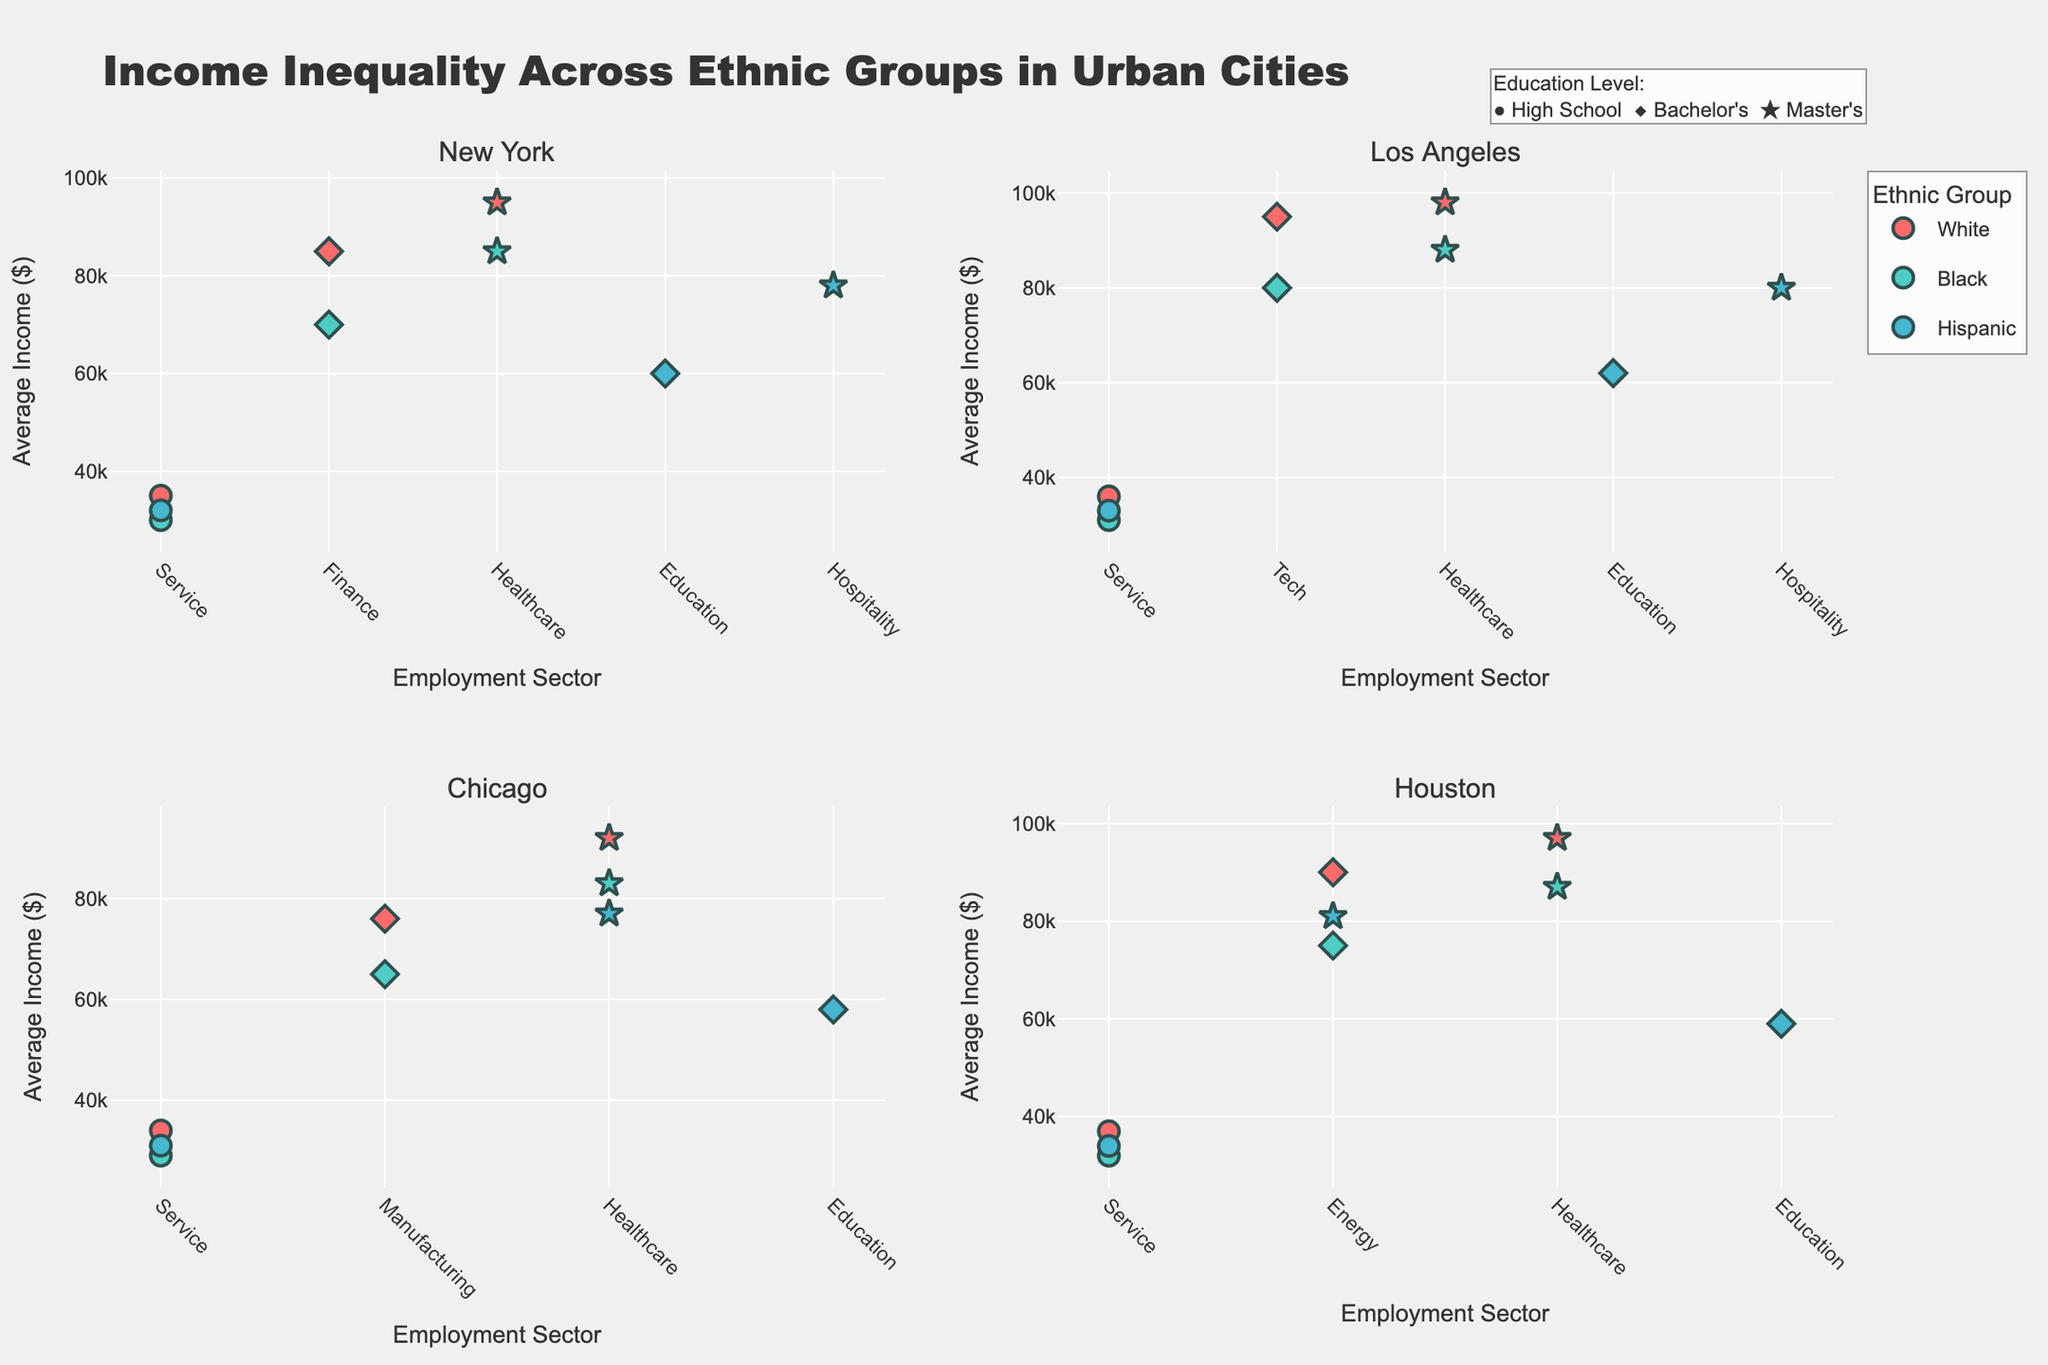What is the average income for Black individuals with a Master's degree in Chicago? To find the average income for Black individuals with a Master's degree in Chicago, look for the respective marker in the Chicago subplot. You will see the income is $83,000.
Answer: $83,000 Which ethnic group in New York has the lowest average income, and in which sector? Examine all markers in the New York subplot. The Black ethnic group in the service sector has an average income of $30,000, which is the lowest.
Answer: Black in Service Is there a noticeable difference in incomes between Master’s degree holders in healthcare across cities? Look at the markers representing Master's degree in healthcare across different cities. The incomes are $95,000 in New York, $98,000 in Los Angeles, $92,000 in Chicago, and $97,000 in Houston. The differences are relatively small.
Answer: Only slight differences How does the average income of Hispanic individuals with a Bachelor's degree in Education in Los Angeles compare to that in Houston? Look at the diamond markers for Hispanic individuals in the Education sector in both Los Angeles and Houston. In Los Angeles, the income is $62,000, while in Houston, it is $59,000.
Answer: $62,000 vs $59,000 Is there a correlation between education level and average income for White individuals in New York? Compare the markers for White individuals in different education levels in New York. High School income is $35,000, Bachelor's is $85,000, and Master's is $95,000. Higher education levels correlate with higher incomes.
Answer: Positive correlation Which city has the highest average income for white individuals with a Bachelor's degree, and what is that income? Check the diamond markers for White individuals across all cities. Los Angeles has the highest income at $95,000.
Answer: Los Angeles with $95,000 What is the income disparity between Black individuals with a high school diploma and those with a Master’s degree in Houston? Compare the high school and Master's income for Black individuals in Houston. High School income is $32,000, and Master's income is $87,000. The disparity is $87,000 - $32,000 = $55,000.
Answer: $55,000 In Los Angeles, which ethnic group in the Service sector has the highest average income, and how much is it? Look at the Service sector markers in Los Angeles for all ethnic groups. The White ethnic group in the Service sector has the highest income at $36,000.
Answer: White with $36,000 